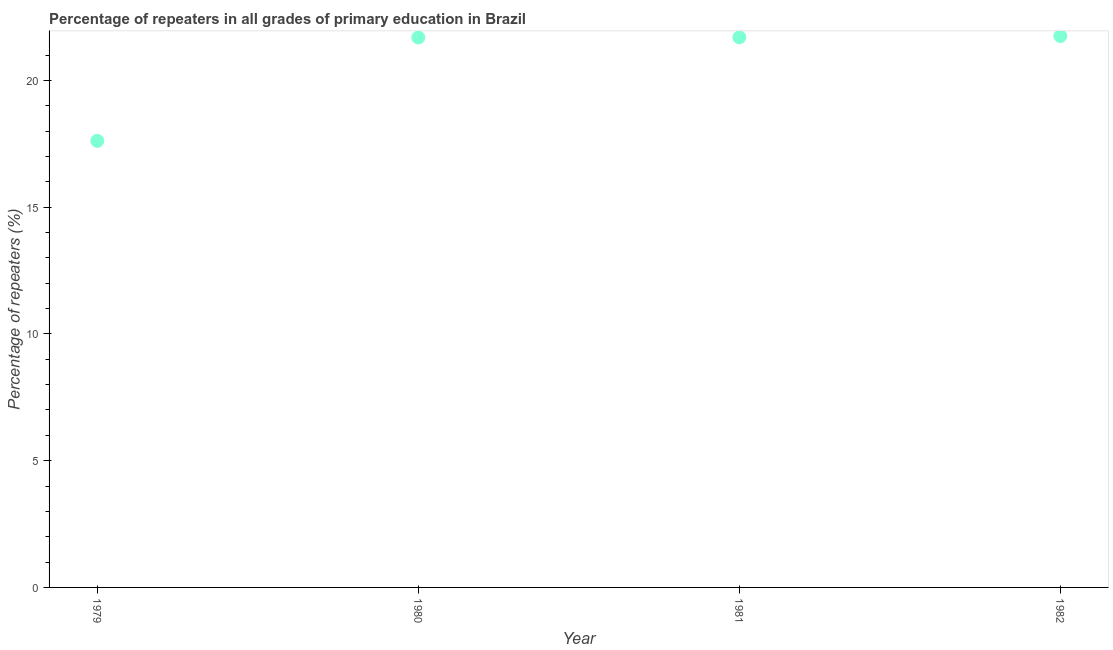What is the percentage of repeaters in primary education in 1979?
Your answer should be very brief. 17.62. Across all years, what is the maximum percentage of repeaters in primary education?
Offer a very short reply. 21.75. Across all years, what is the minimum percentage of repeaters in primary education?
Ensure brevity in your answer.  17.62. In which year was the percentage of repeaters in primary education maximum?
Ensure brevity in your answer.  1982. In which year was the percentage of repeaters in primary education minimum?
Make the answer very short. 1979. What is the sum of the percentage of repeaters in primary education?
Ensure brevity in your answer.  82.76. What is the difference between the percentage of repeaters in primary education in 1979 and 1982?
Make the answer very short. -4.14. What is the average percentage of repeaters in primary education per year?
Your answer should be very brief. 20.69. What is the median percentage of repeaters in primary education?
Provide a succinct answer. 21.7. In how many years, is the percentage of repeaters in primary education greater than 18 %?
Your answer should be compact. 3. Do a majority of the years between 1980 and 1981 (inclusive) have percentage of repeaters in primary education greater than 7 %?
Ensure brevity in your answer.  Yes. What is the ratio of the percentage of repeaters in primary education in 1980 to that in 1982?
Give a very brief answer. 1. What is the difference between the highest and the second highest percentage of repeaters in primary education?
Make the answer very short. 0.05. What is the difference between the highest and the lowest percentage of repeaters in primary education?
Provide a short and direct response. 4.14. Does the percentage of repeaters in primary education monotonically increase over the years?
Your response must be concise. Yes. How many dotlines are there?
Provide a succinct answer. 1. Are the values on the major ticks of Y-axis written in scientific E-notation?
Offer a terse response. No. Does the graph contain any zero values?
Provide a succinct answer. No. Does the graph contain grids?
Ensure brevity in your answer.  No. What is the title of the graph?
Keep it short and to the point. Percentage of repeaters in all grades of primary education in Brazil. What is the label or title of the X-axis?
Keep it short and to the point. Year. What is the label or title of the Y-axis?
Your response must be concise. Percentage of repeaters (%). What is the Percentage of repeaters (%) in 1979?
Your answer should be compact. 17.62. What is the Percentage of repeaters (%) in 1980?
Make the answer very short. 21.69. What is the Percentage of repeaters (%) in 1981?
Offer a very short reply. 21.7. What is the Percentage of repeaters (%) in 1982?
Provide a succinct answer. 21.75. What is the difference between the Percentage of repeaters (%) in 1979 and 1980?
Your answer should be very brief. -4.08. What is the difference between the Percentage of repeaters (%) in 1979 and 1981?
Ensure brevity in your answer.  -4.09. What is the difference between the Percentage of repeaters (%) in 1979 and 1982?
Your answer should be very brief. -4.14. What is the difference between the Percentage of repeaters (%) in 1980 and 1981?
Provide a succinct answer. -0.01. What is the difference between the Percentage of repeaters (%) in 1980 and 1982?
Your answer should be compact. -0.06. What is the difference between the Percentage of repeaters (%) in 1981 and 1982?
Provide a short and direct response. -0.05. What is the ratio of the Percentage of repeaters (%) in 1979 to that in 1980?
Give a very brief answer. 0.81. What is the ratio of the Percentage of repeaters (%) in 1979 to that in 1981?
Your answer should be compact. 0.81. What is the ratio of the Percentage of repeaters (%) in 1979 to that in 1982?
Offer a very short reply. 0.81. 